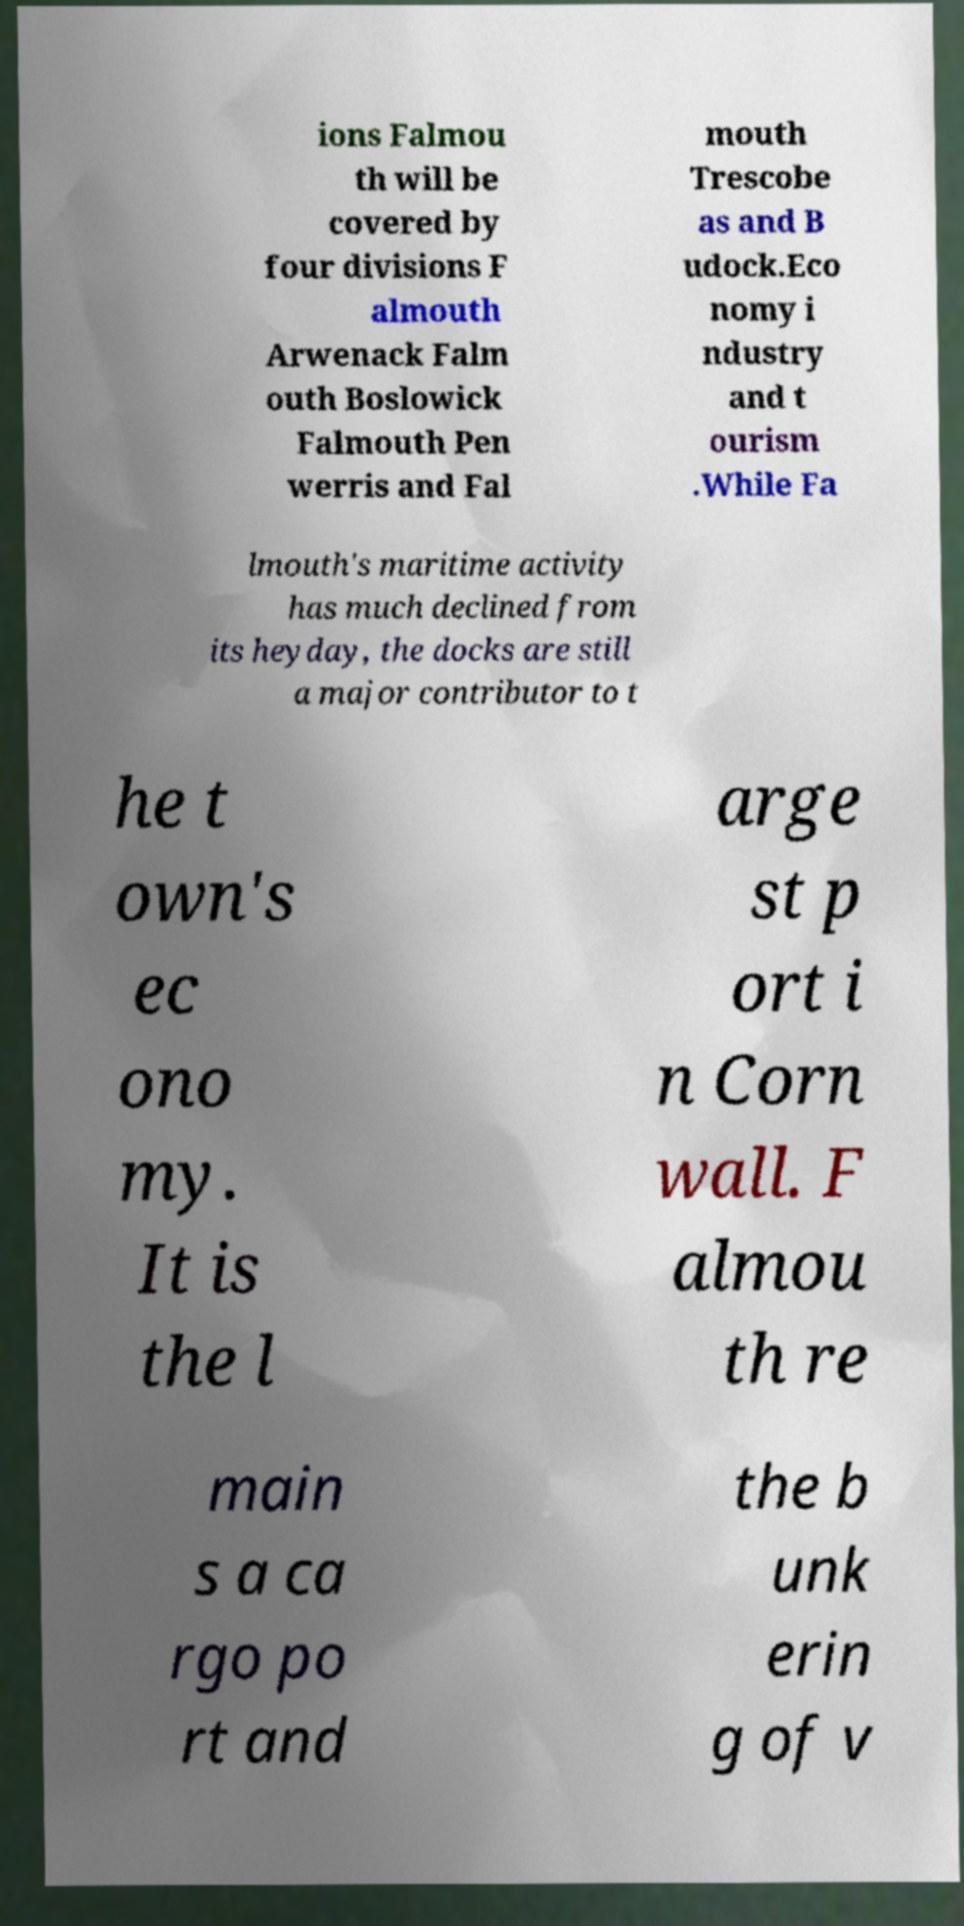For documentation purposes, I need the text within this image transcribed. Could you provide that? ions Falmou th will be covered by four divisions F almouth Arwenack Falm outh Boslowick Falmouth Pen werris and Fal mouth Trescobe as and B udock.Eco nomy i ndustry and t ourism .While Fa lmouth's maritime activity has much declined from its heyday, the docks are still a major contributor to t he t own's ec ono my. It is the l arge st p ort i n Corn wall. F almou th re main s a ca rgo po rt and the b unk erin g of v 